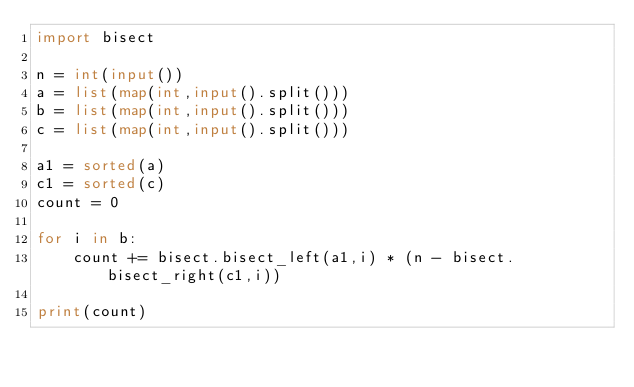<code> <loc_0><loc_0><loc_500><loc_500><_Python_>import bisect

n = int(input())
a = list(map(int,input().split()))
b = list(map(int,input().split()))
c = list(map(int,input().split()))

a1 = sorted(a)
c1 = sorted(c)
count = 0

for i in b:
    count += bisect.bisect_left(a1,i) * (n - bisect.bisect_right(c1,i))
    
print(count)</code> 